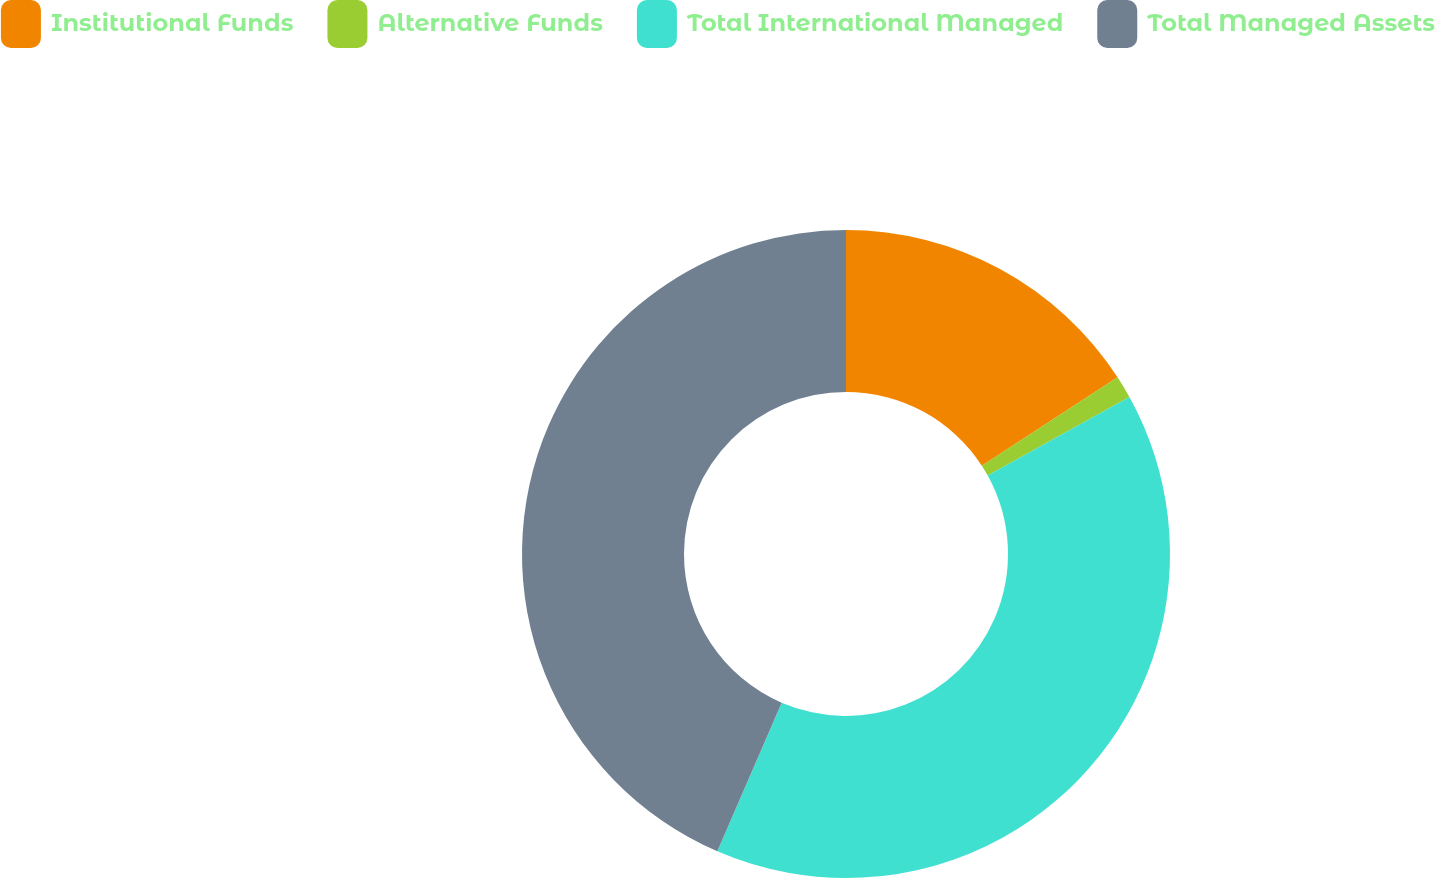Convert chart to OTSL. <chart><loc_0><loc_0><loc_500><loc_500><pie_chart><fcel>Institutional Funds<fcel>Alternative Funds<fcel>Total International Managed<fcel>Total Managed Assets<nl><fcel>15.82%<fcel>1.13%<fcel>39.55%<fcel>43.5%<nl></chart> 